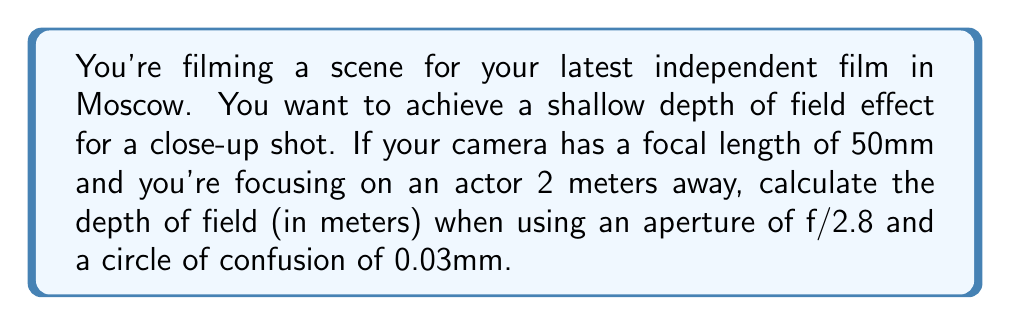Show me your answer to this math problem. To calculate the depth of field, we'll use the following steps and formulas:

1. Calculate the hyperfocal distance (H):
   $$H = \frac{f^2}{N \cdot c} + f$$
   Where f is focal length, N is f-number, and c is circle of confusion.

2. Calculate the near limit of acceptable sharpness (Dn):
   $$D_n = \frac{s \cdot (H - f)}{H + s - 2f}$$
   Where s is the subject distance.

3. Calculate the far limit of acceptable sharpness (Df):
   $$D_f = \frac{s \cdot (H - f)}{H - s}$$

4. Calculate the depth of field by subtracting Dn from Df.

Step 1: Calculate the hyperfocal distance
$$H = \frac{50^2}{2.8 \cdot 0.03} + 50 = 29,761.90 \text{ mm} = 29.76 \text{ m}$$

Step 2: Calculate the near limit
$$D_n = \frac{2 \cdot (29.76 - 0.05)}{29.76 + 2 - 2(0.05)} = 1.87 \text{ m}$$

Step 3: Calculate the far limit
$$D_f = \frac{2 \cdot (29.76 - 0.05)}{29.76 - 2} = 2.15 \text{ m}$$

Step 4: Calculate the depth of field
Depth of Field = $D_f - D_n = 2.15 - 1.87 = 0.28 \text{ m}$
Answer: 0.28 m 